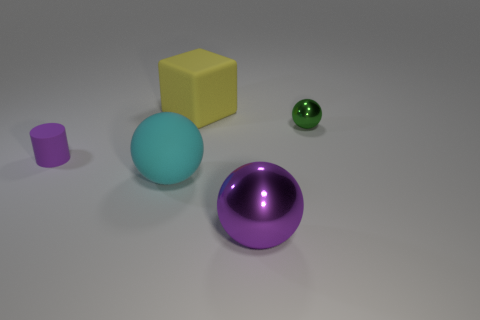What color is the tiny thing that is in front of the metal object behind the small purple matte cylinder to the left of the small ball?
Ensure brevity in your answer.  Purple. How many other things are there of the same color as the large shiny thing?
Provide a succinct answer. 1. How many rubber objects are either blocks or purple balls?
Your answer should be very brief. 1. There is a large rubber object that is behind the cylinder; does it have the same color as the small thing behind the purple matte thing?
Keep it short and to the point. No. Are there any other things that have the same material as the large yellow block?
Give a very brief answer. Yes. There is another purple shiny object that is the same shape as the tiny shiny thing; what size is it?
Offer a terse response. Large. Are there more purple things that are right of the tiny shiny sphere than small cyan shiny things?
Give a very brief answer. No. Is the material of the tiny object to the right of the large matte ball the same as the big purple ball?
Ensure brevity in your answer.  Yes. There is a sphere behind the small object that is on the left side of the large rubber object in front of the tiny green object; what is its size?
Make the answer very short. Small. There is a cyan object that is made of the same material as the cylinder; what is its size?
Your response must be concise. Large. 